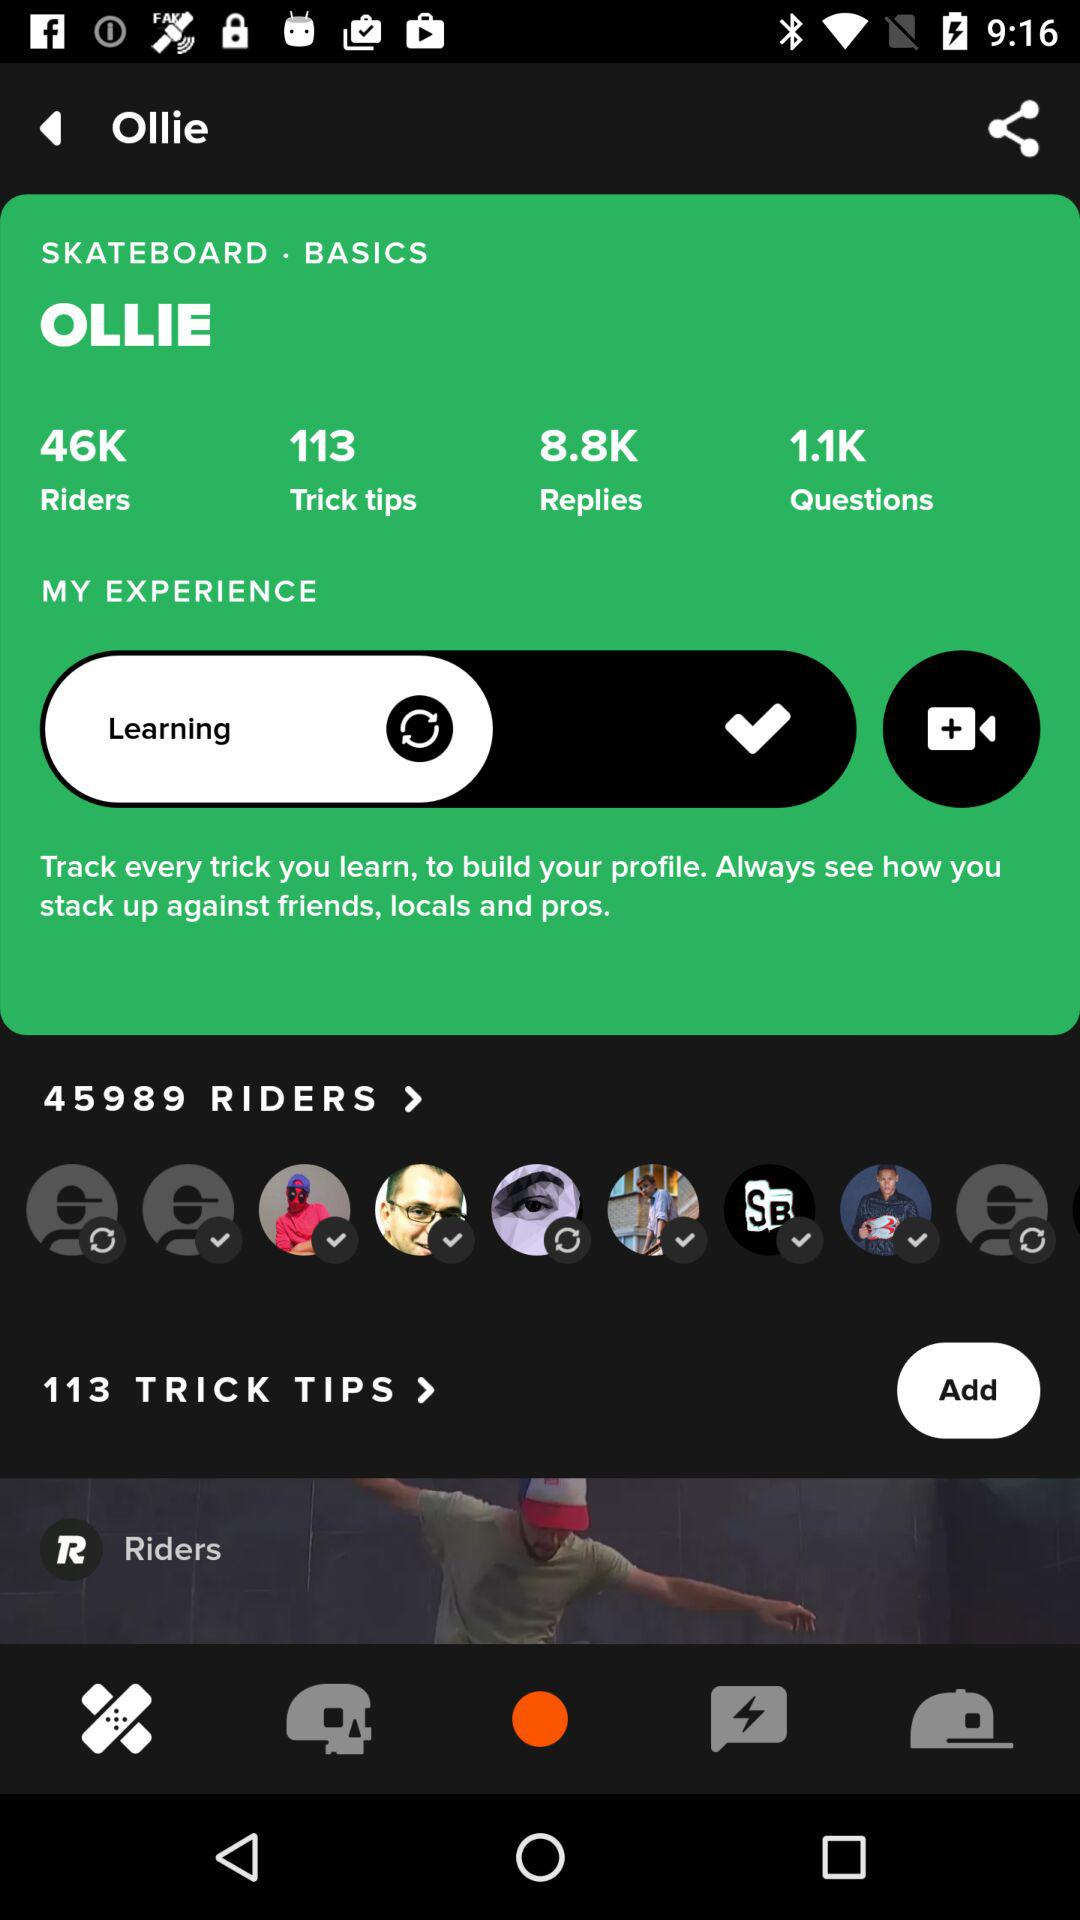What's the status of "MY EXPERIENCE"? The status of "MY EXPERIENCE" is "Learning". 